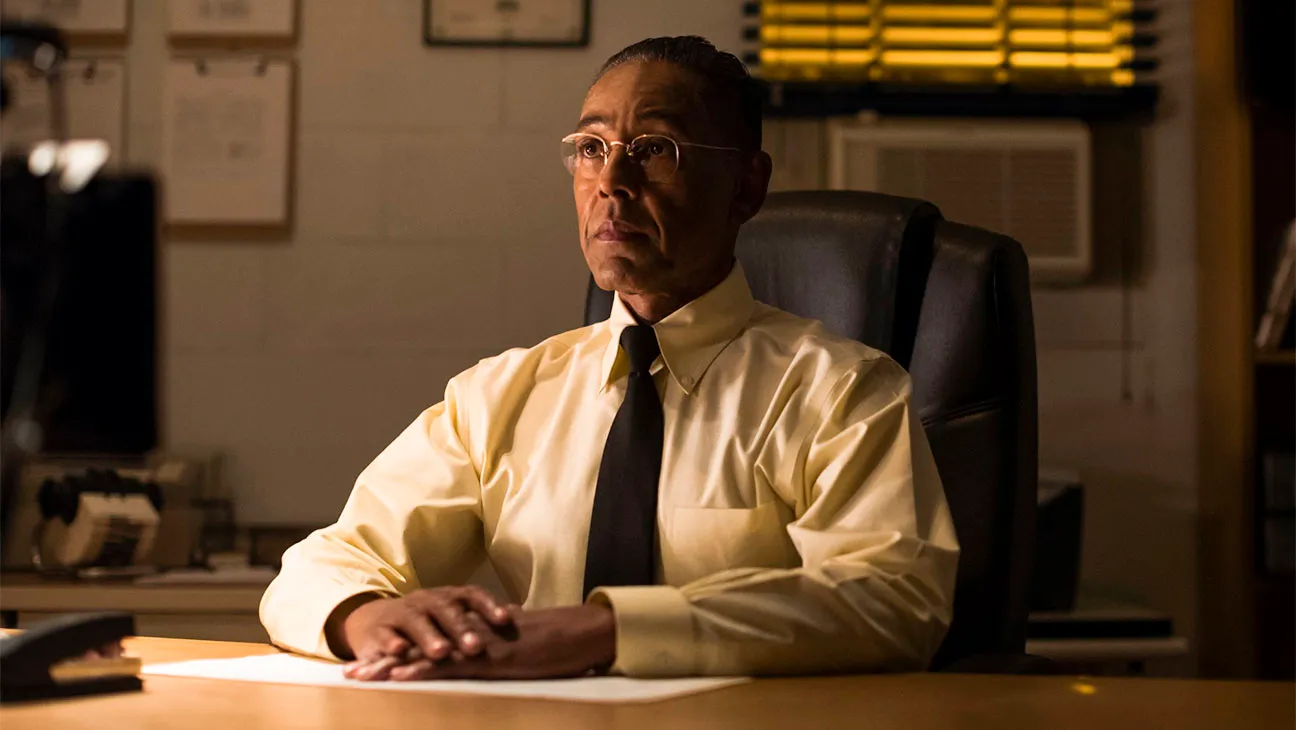Describe the mood and atmosphere of the office setting in the image. The mood and atmosphere of the office in the image are somber and serious. The dim lighting casts long shadows, creating a sense of isolation and introspection. The yellow blinds on the window add a muted warmth, contrasting with the otherwise cool and subdued tones of the room. The man seated at the desk, with his serious demeanor and business attire, further enhances the formal and contemplative mood of the scene. It feels as though this is a place where important and possibly heavy decisions are made, a setting that demands focus and deliberation. Could this image be from a noir film? Why or why not? This image could indeed be a still from a noir film. The somber and serious atmosphere, along with the dim lighting and shadows, are characteristic elements of the noir genre. The man's intense expression and formal attire add to this aesthetic, suggesting a narrative filled with intrigue, conflict, and complex moral choices. The yellow blinds contribute to the visual style often seen in noir films, providing a backdrop of mystery and seclusion. If this character had a secret, what might it be? If this character had a secret, it might be that he is not just an ordinary office worker but a key player in a hidden network of informants and spies. By day, he appears to be a diligent and unassuming employee, but by night, he coordinates covert operations and gathers intelligence critical to national security. He holds vital information that if exposed, could alter the balance of power in his organization. This dual life weighs heavily on him, as he navigates the fine line between his public facade and his clandestine activities. What kind of music do you think he listens to when he is alone? When he is alone, he might listen to classical music or jazz. The intricate and sophisticated compositions of classical pieces could resonate with his thoughtful and meticulous nature, providing a backdrop for his deep contemplation. Jazz, with its complex and often improvisational structure, might reflect the constantly shifting challenges he faces in his secretive work. 